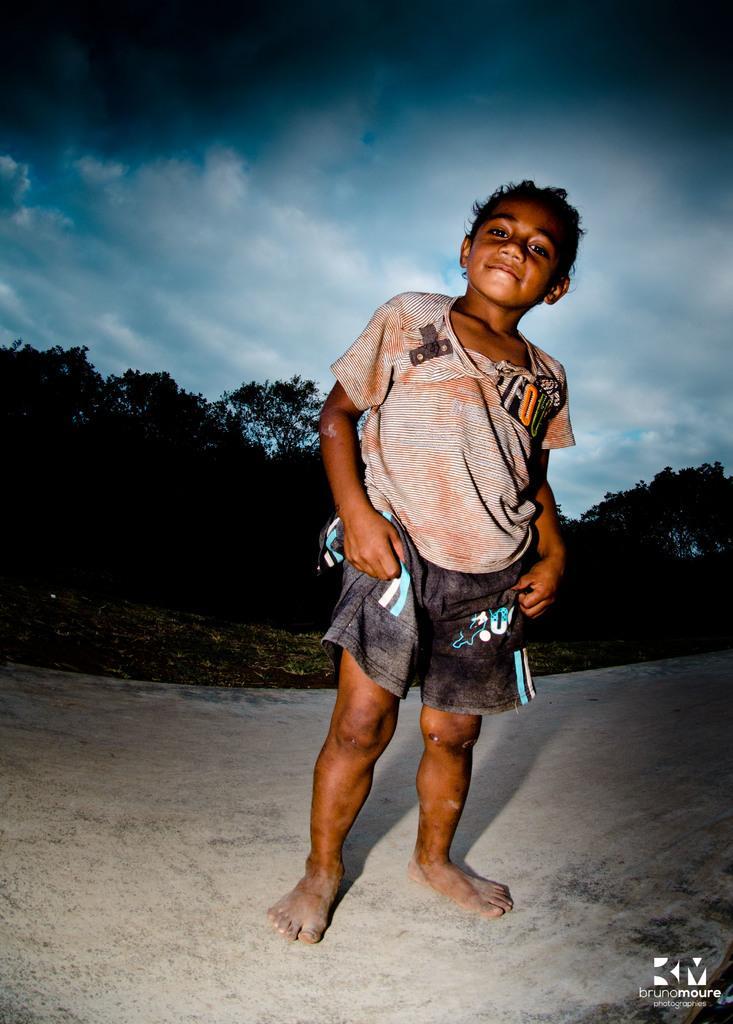Describe this image in one or two sentences. In the center of the image we can see a boy is standing. In the background of the image we can see the trees. At the bottom of the image we can see the road. In the bottom right corner we can see the text and logo. At the top of the image we can see the clouds are present in the sky. 